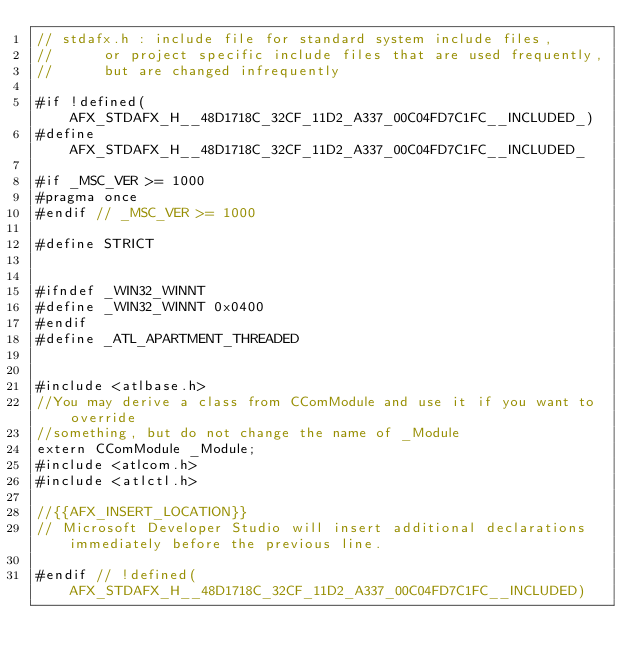Convert code to text. <code><loc_0><loc_0><loc_500><loc_500><_C_>// stdafx.h : include file for standard system include files,
//      or project specific include files that are used frequently,
//      but are changed infrequently

#if !defined(AFX_STDAFX_H__48D1718C_32CF_11D2_A337_00C04FD7C1FC__INCLUDED_)
#define AFX_STDAFX_H__48D1718C_32CF_11D2_A337_00C04FD7C1FC__INCLUDED_

#if _MSC_VER >= 1000
#pragma once
#endif // _MSC_VER >= 1000

#define STRICT


#ifndef _WIN32_WINNT
#define _WIN32_WINNT 0x0400
#endif
#define _ATL_APARTMENT_THREADED


#include <atlbase.h>
//You may derive a class from CComModule and use it if you want to override
//something, but do not change the name of _Module
extern CComModule _Module;
#include <atlcom.h>
#include <atlctl.h>

//{{AFX_INSERT_LOCATION}}
// Microsoft Developer Studio will insert additional declarations immediately before the previous line.

#endif // !defined(AFX_STDAFX_H__48D1718C_32CF_11D2_A337_00C04FD7C1FC__INCLUDED)
</code> 